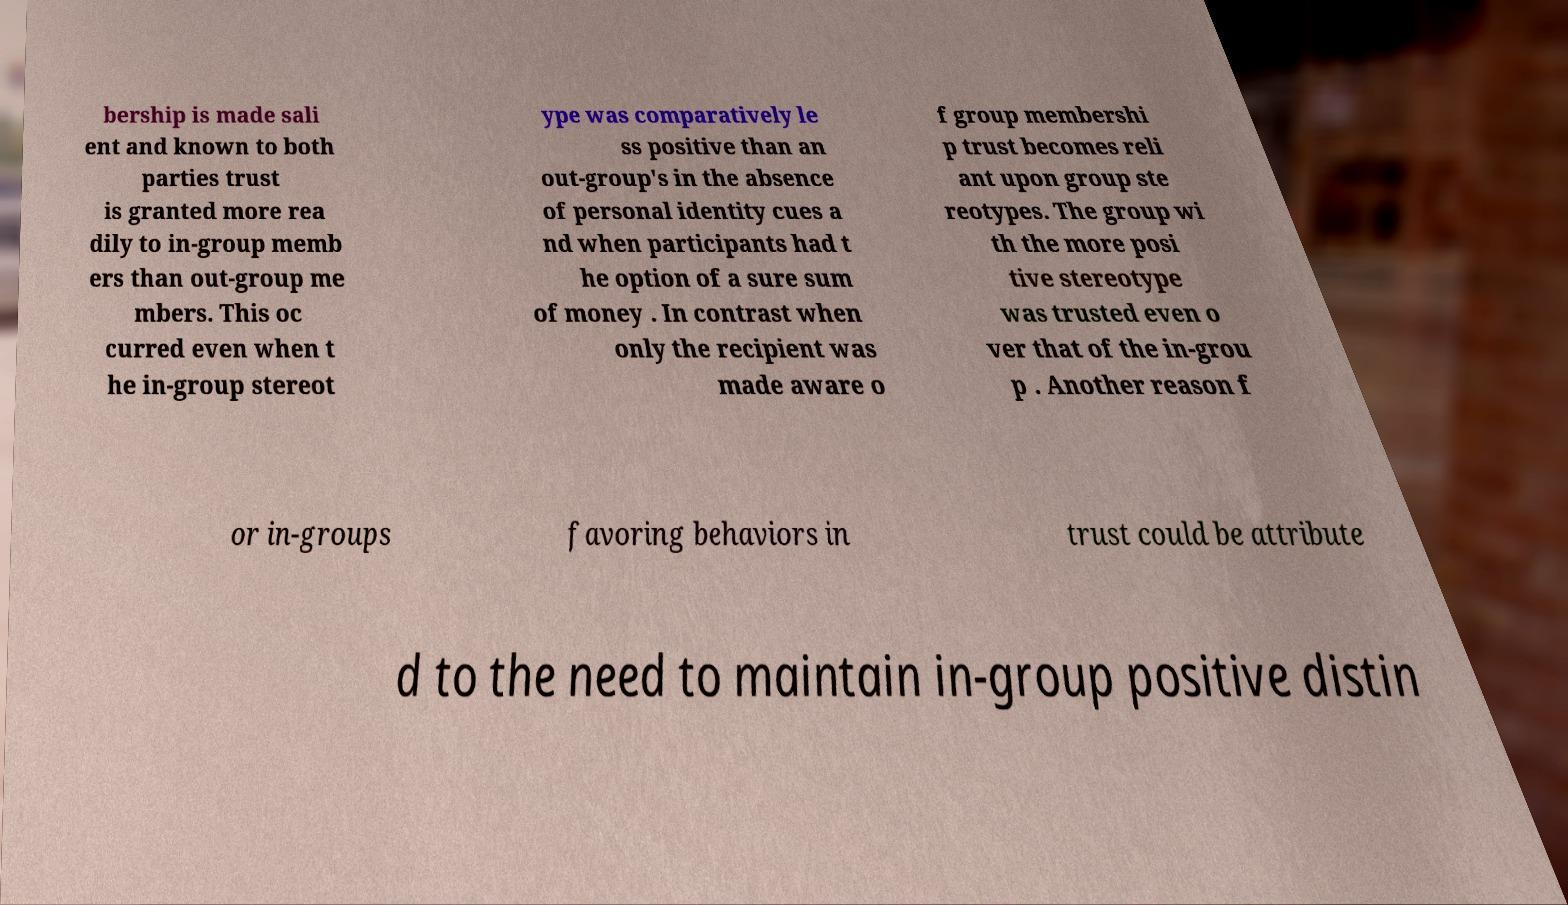Could you assist in decoding the text presented in this image and type it out clearly? bership is made sali ent and known to both parties trust is granted more rea dily to in-group memb ers than out-group me mbers. This oc curred even when t he in-group stereot ype was comparatively le ss positive than an out-group's in the absence of personal identity cues a nd when participants had t he option of a sure sum of money . In contrast when only the recipient was made aware o f group membershi p trust becomes reli ant upon group ste reotypes. The group wi th the more posi tive stereotype was trusted even o ver that of the in-grou p . Another reason f or in-groups favoring behaviors in trust could be attribute d to the need to maintain in-group positive distin 